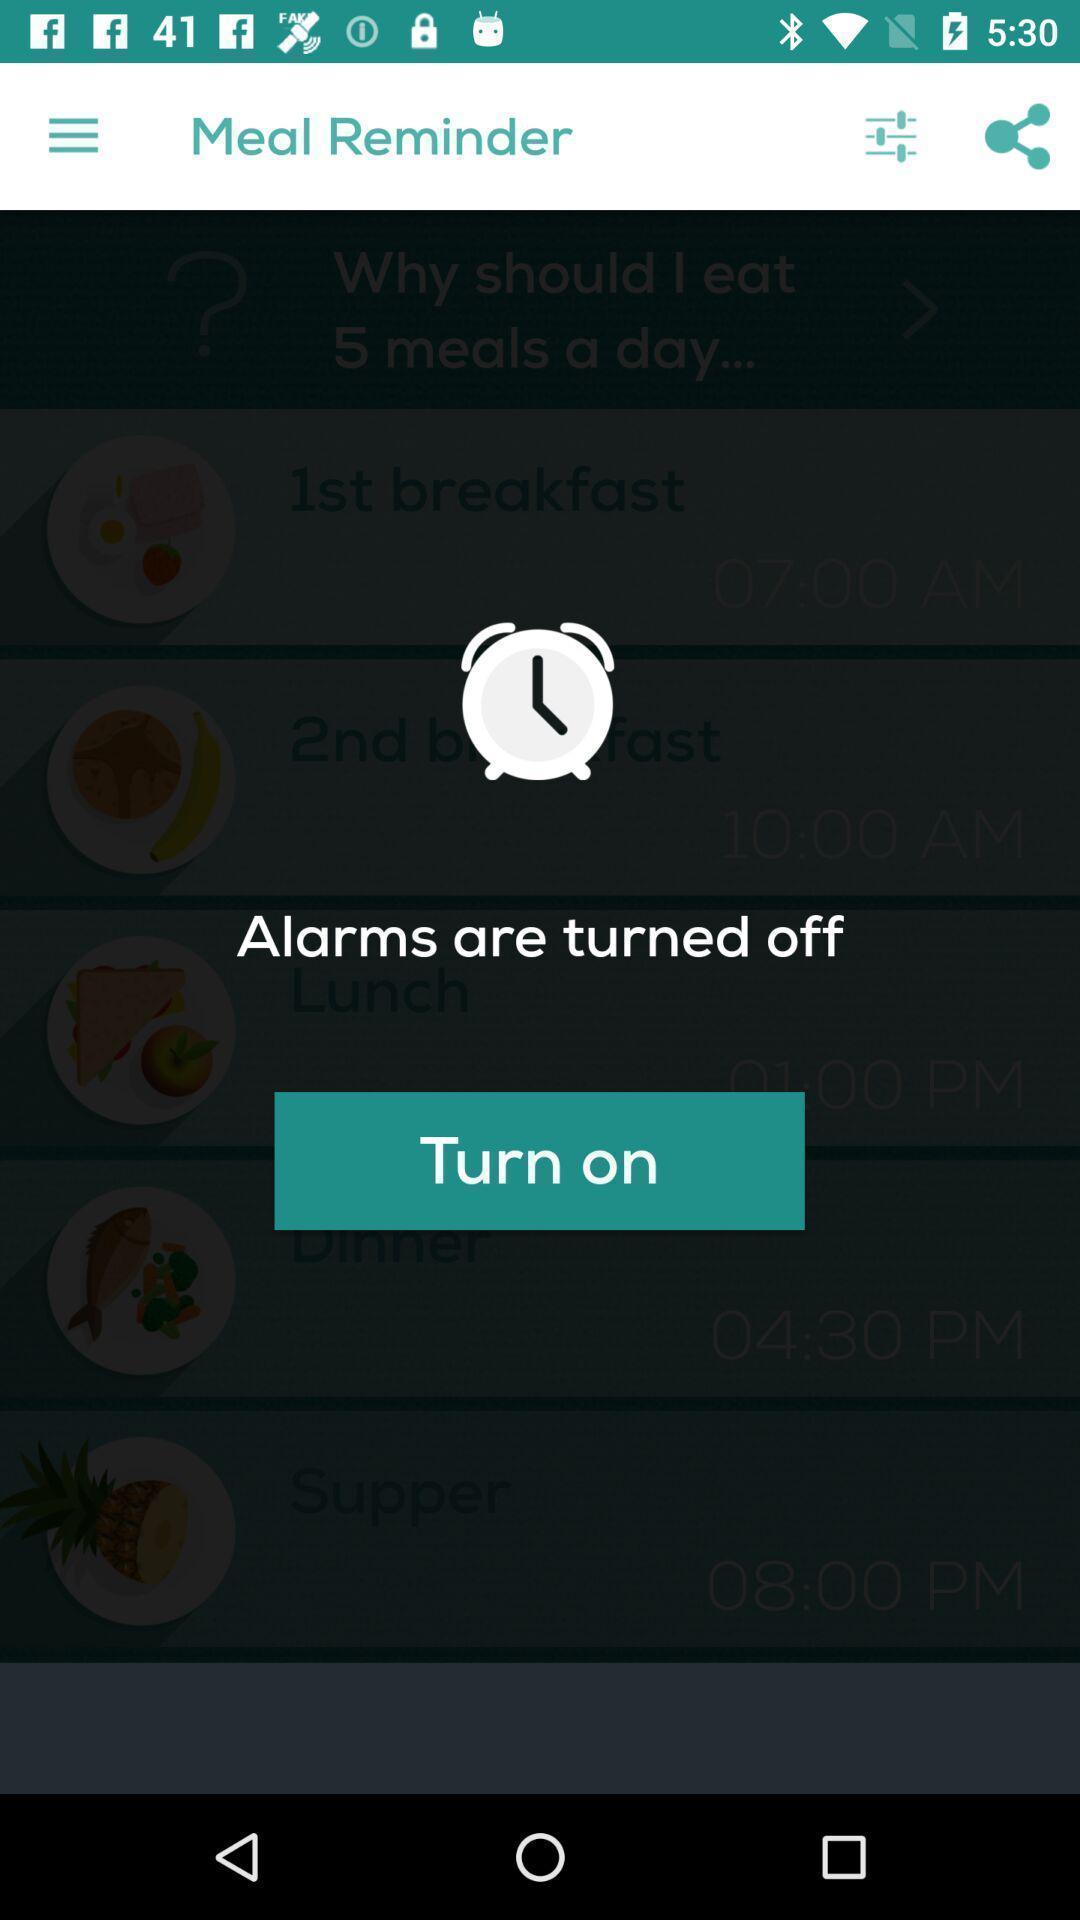Describe the key features of this screenshot. Popup showing about remainder notifications. 